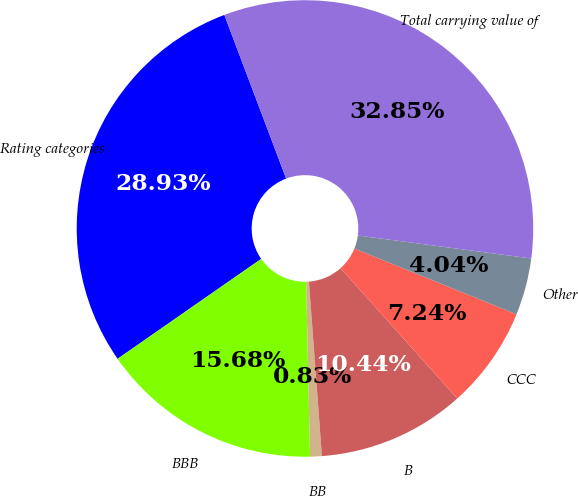Convert chart to OTSL. <chart><loc_0><loc_0><loc_500><loc_500><pie_chart><fcel>Rating categories<fcel>BBB<fcel>BB<fcel>B<fcel>CCC<fcel>Other<fcel>Total carrying value of<nl><fcel>28.93%<fcel>15.68%<fcel>0.83%<fcel>10.44%<fcel>7.24%<fcel>4.04%<fcel>32.85%<nl></chart> 